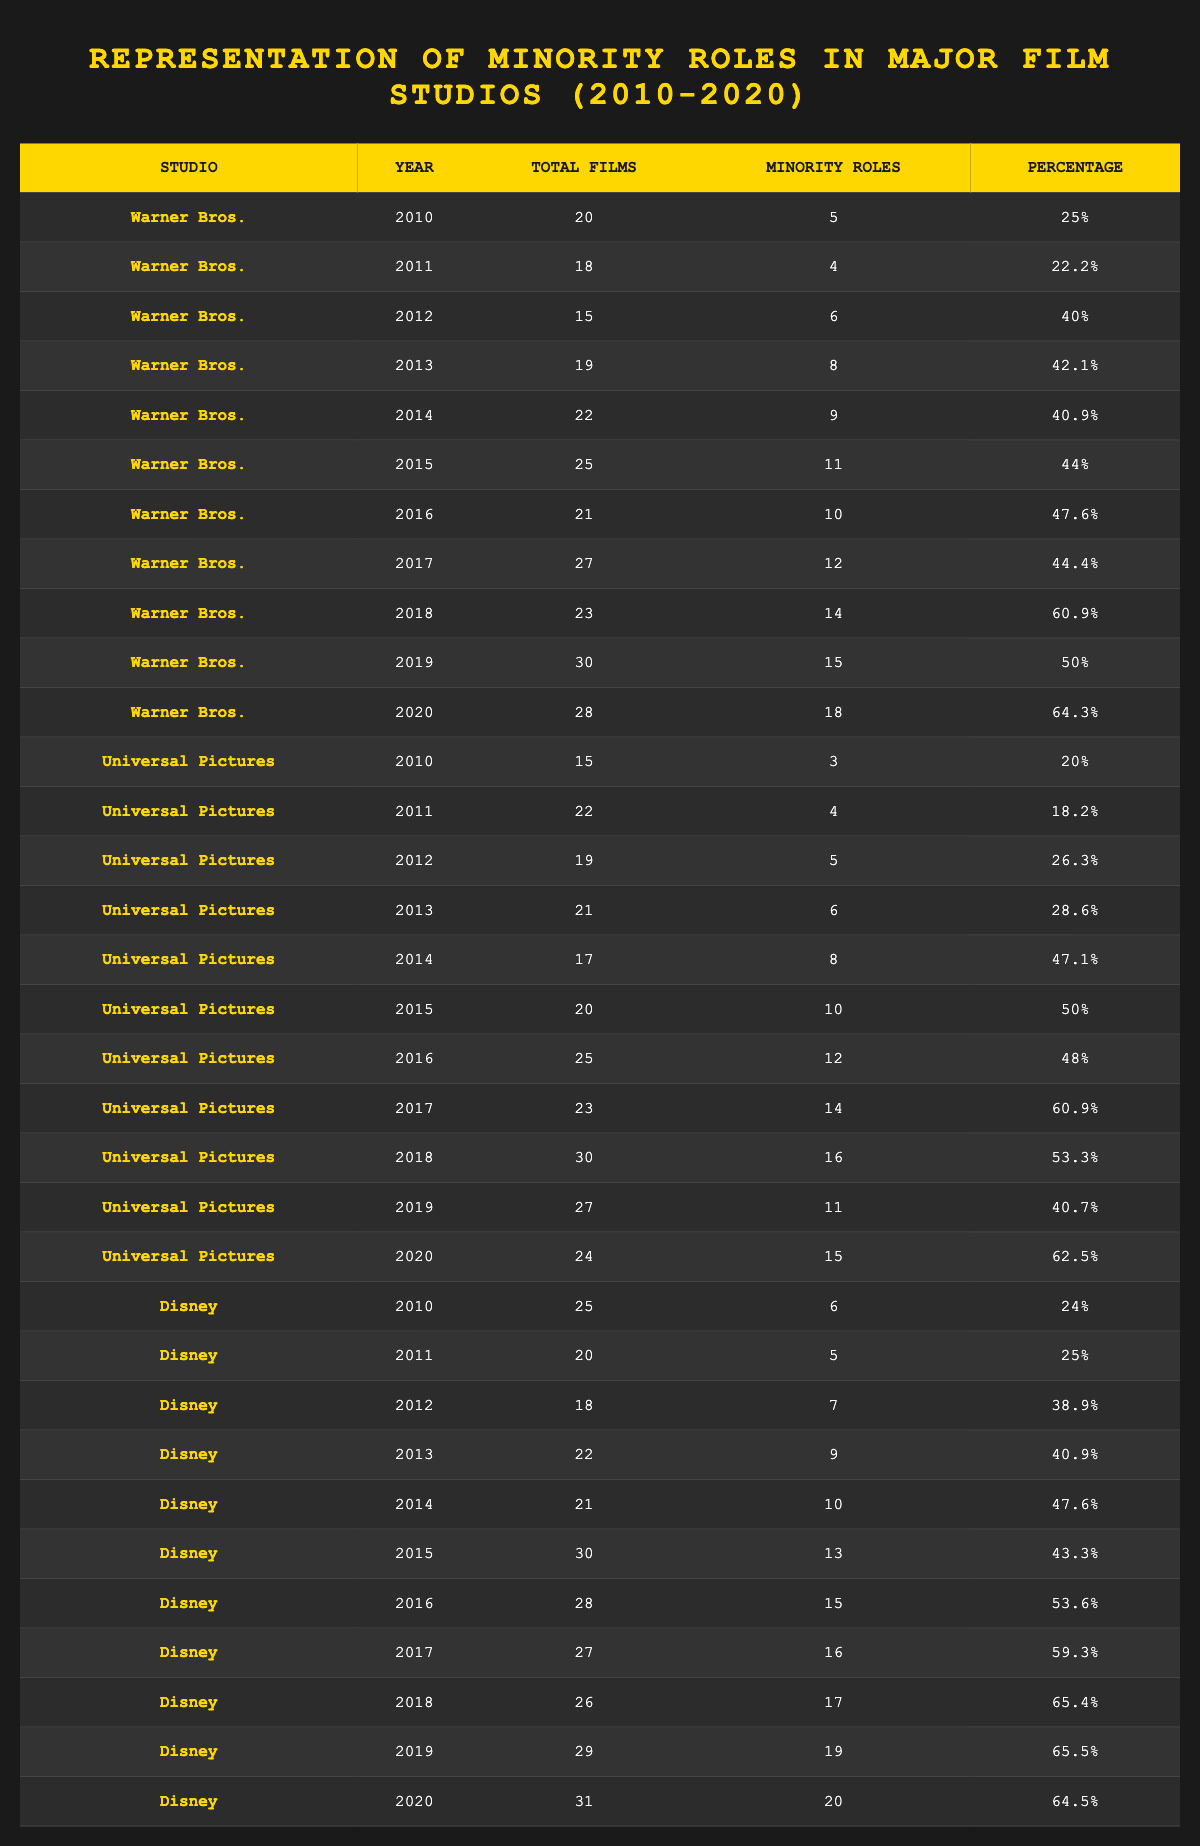What was the percentage representation of minority roles in Warner Bros. films in 2014? In the table, I look for the row where the studio is Warner Bros. and the year is 2014. The data shows that the percentage representation of minority roles is 40.9%.
Answer: 40.9% Which studio had the highest percentage representation of minority roles in 2018? I compare the percentage representation for each studio in the year 2018. Warner Bros. had 60.9%, Universal Pictures had 53.3%, and Disney had 65.4%. The highest percentage is from Disney with 65.4%.
Answer: Disney What is the total number of films released by Universal Pictures from 2010 to 2020? To answer this, I sum the total films for each year (15 + 22 + 19 + 21 + 17 + 20 + 25 + 23 + 30 + 27 + 24) =  15 + 22 + 19 + 21 + 17 + 20 + 25 + 23 + 30 + 27 + 24 =  27 + 25 + 19 + 21 + 15 + 22 + 30 = 230.
Answer: 230 In which year did Warner Bros. have the lowest number of minority roles? I review the data for Warner Bros. and find that in 2011, they had the lowest number of minority roles recorded, which is 4.
Answer: 2011 Is it true that Disney had more minority roles than Universal Pictures in every year from 2010 to 2020? I must examine the minority roles for both studios across the years. In 2010, Disney had 6 and Universal had 3 (Disney fits), in 2011, Disney had 5 and Universal had 4 (Disney fits), in 2012, Disney had 7 and Universal had 5 (Disney fits), and this continues to 2014. But in 2014, Universal Pictures had 8, and Disney had 10 (Disney fits), so it is not true because the statement doesn't hold for every year.
Answer: No What was the average percentage representation of minority roles for Disney from 2010 to 2020? First, I sum the percentage representations for Disney across the years: (24 + 25 + 38.9 + 40.9 + 47.6 + 43.3 + 53.6 + 59.3 + 65.4 + 65.5 + 64.5) and find their total is  24 + 25 + 39 + 41 + 48 + 43 + 54 + 59 + 65 + 65 + 64 = 558. Then I divide by the number of years, which is 11: 558 / 11 = 50.727.
Answer: 50.73 